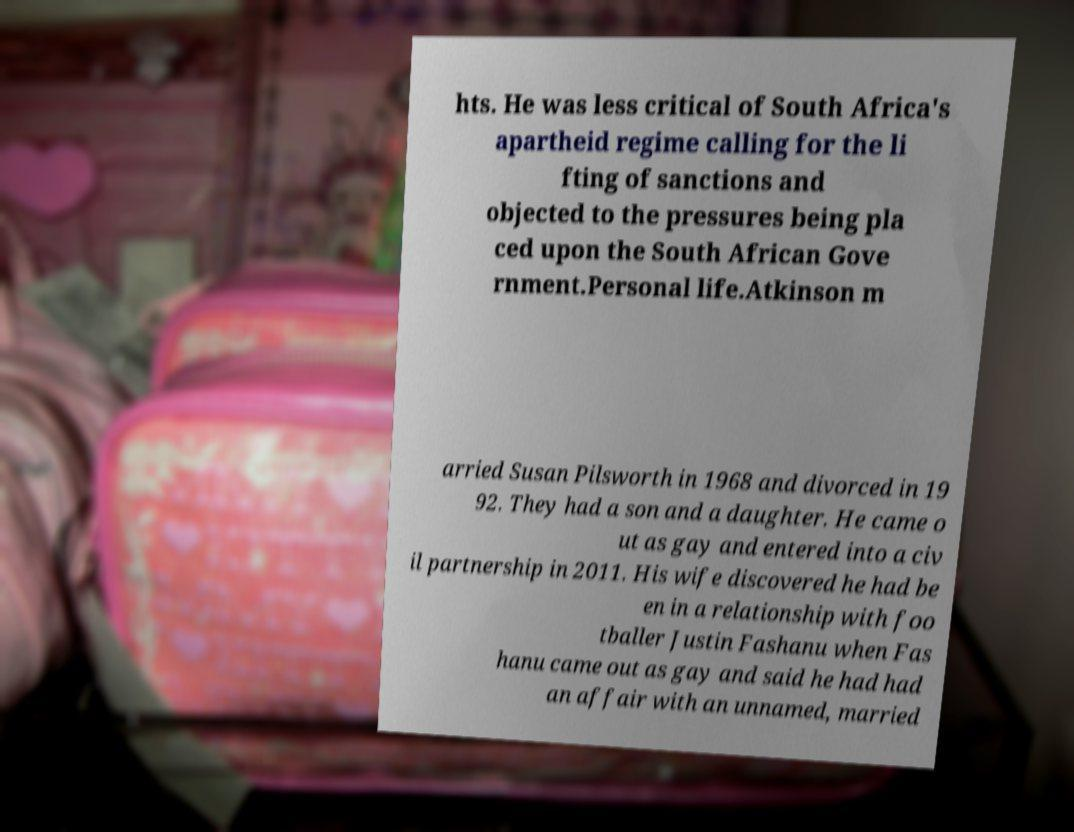Can you read and provide the text displayed in the image?This photo seems to have some interesting text. Can you extract and type it out for me? hts. He was less critical of South Africa's apartheid regime calling for the li fting of sanctions and objected to the pressures being pla ced upon the South African Gove rnment.Personal life.Atkinson m arried Susan Pilsworth in 1968 and divorced in 19 92. They had a son and a daughter. He came o ut as gay and entered into a civ il partnership in 2011. His wife discovered he had be en in a relationship with foo tballer Justin Fashanu when Fas hanu came out as gay and said he had had an affair with an unnamed, married 